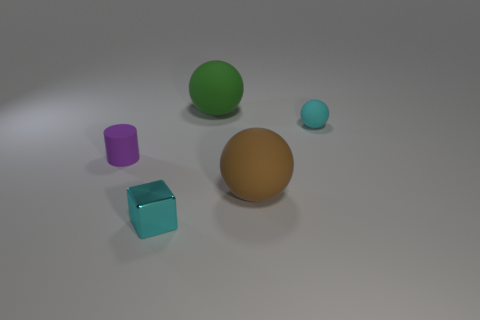There is a large rubber ball in front of the big green rubber ball; are there any green things left of it?
Provide a succinct answer. Yes. What number of objects are green things or metal blocks?
Make the answer very short. 2. There is a small object on the left side of the tiny cyan object that is on the left side of the large ball that is to the right of the green ball; what is its color?
Keep it short and to the point. Purple. Are there any other things that are the same color as the metallic thing?
Your response must be concise. Yes. Do the shiny cube and the cyan rubber thing have the same size?
Offer a very short reply. Yes. What number of objects are either cyan objects in front of the purple rubber object or cyan objects on the left side of the small cyan matte thing?
Your response must be concise. 1. The small object on the right side of the tiny cyan object in front of the small purple matte cylinder is made of what material?
Give a very brief answer. Rubber. What number of other things are there of the same material as the tiny block
Your answer should be very brief. 0. Do the cyan rubber thing and the green object have the same shape?
Offer a terse response. Yes. There is a cyan object that is in front of the small cyan rubber object; how big is it?
Your response must be concise. Small. 